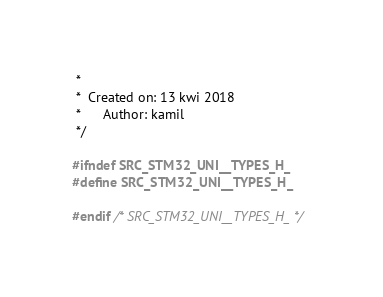<code> <loc_0><loc_0><loc_500><loc_500><_C_> *
 *  Created on: 13 kwi 2018
 *      Author: kamil
 */

#ifndef SRC_STM32_UNI__TYPES_H_
#define SRC_STM32_UNI__TYPES_H_

#endif /* SRC_STM32_UNI__TYPES_H_ */
</code> 